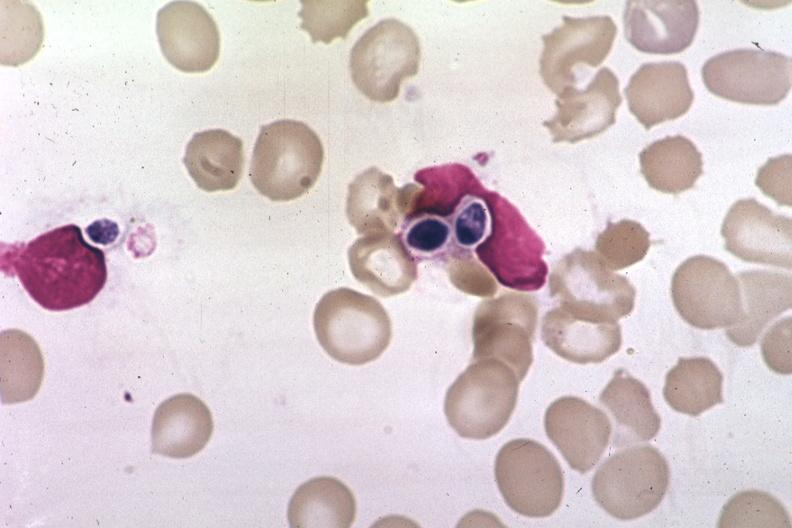does this image show wrights?
Answer the question using a single word or phrase. Yes 